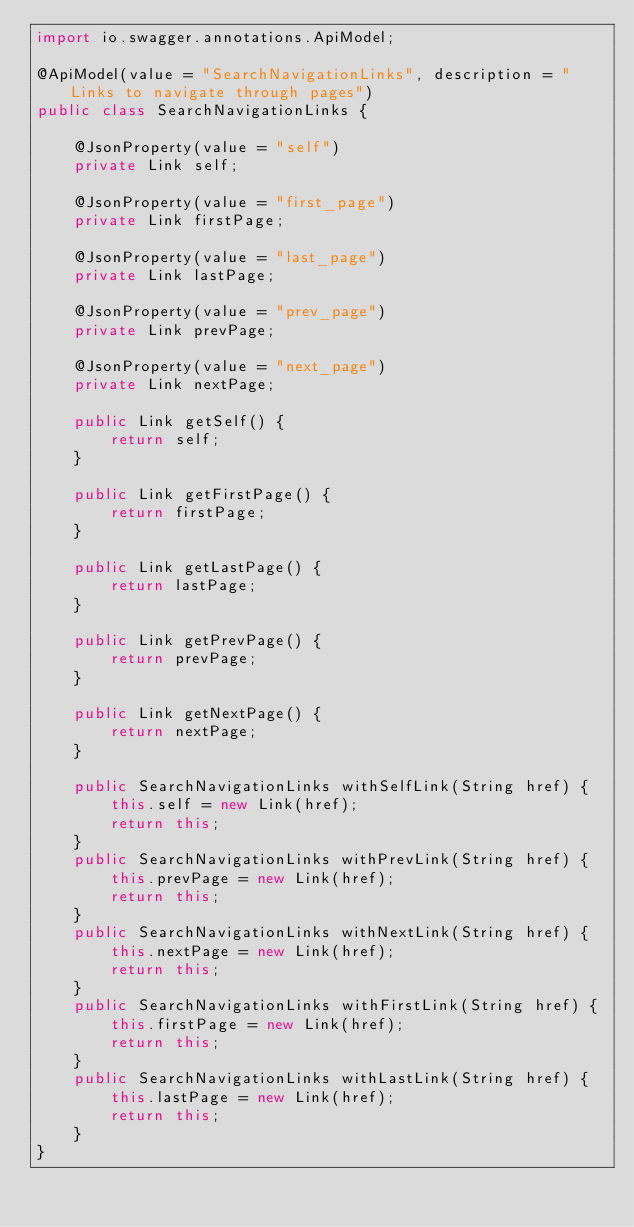Convert code to text. <code><loc_0><loc_0><loc_500><loc_500><_Java_>import io.swagger.annotations.ApiModel;

@ApiModel(value = "SearchNavigationLinks", description = "Links to navigate through pages")
public class SearchNavigationLinks {

    @JsonProperty(value = "self")
    private Link self;

    @JsonProperty(value = "first_page")
    private Link firstPage;

    @JsonProperty(value = "last_page")
    private Link lastPage;

    @JsonProperty(value = "prev_page")
    private Link prevPage;

    @JsonProperty(value = "next_page")
    private Link nextPage;

    public Link getSelf() {
        return self;
    }

    public Link getFirstPage() {
        return firstPage;
    }

    public Link getLastPage() {
        return lastPage;
    }

    public Link getPrevPage() {
        return prevPage;
    }

    public Link getNextPage() {
        return nextPage;
    }

    public SearchNavigationLinks withSelfLink(String href) {
        this.self = new Link(href);
        return this;
    }
    public SearchNavigationLinks withPrevLink(String href) {
        this.prevPage = new Link(href);
        return this;
    }
    public SearchNavigationLinks withNextLink(String href) {
        this.nextPage = new Link(href);
        return this;
    }
    public SearchNavigationLinks withFirstLink(String href) {
        this.firstPage = new Link(href);
        return this;
    }
    public SearchNavigationLinks withLastLink(String href) {
        this.lastPage = new Link(href);
        return this;
    }
}
</code> 